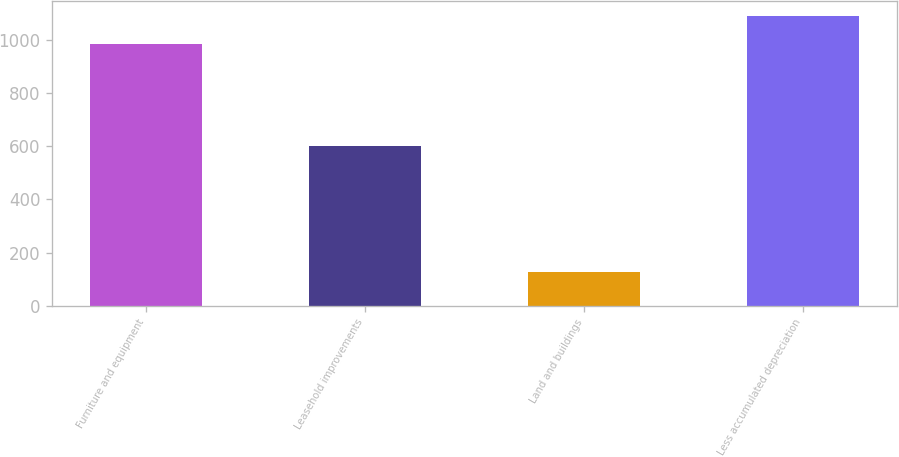Convert chart to OTSL. <chart><loc_0><loc_0><loc_500><loc_500><bar_chart><fcel>Furniture and equipment<fcel>Leasehold improvements<fcel>Land and buildings<fcel>Less accumulated depreciation<nl><fcel>983.2<fcel>599.7<fcel>126.1<fcel>1089<nl></chart> 